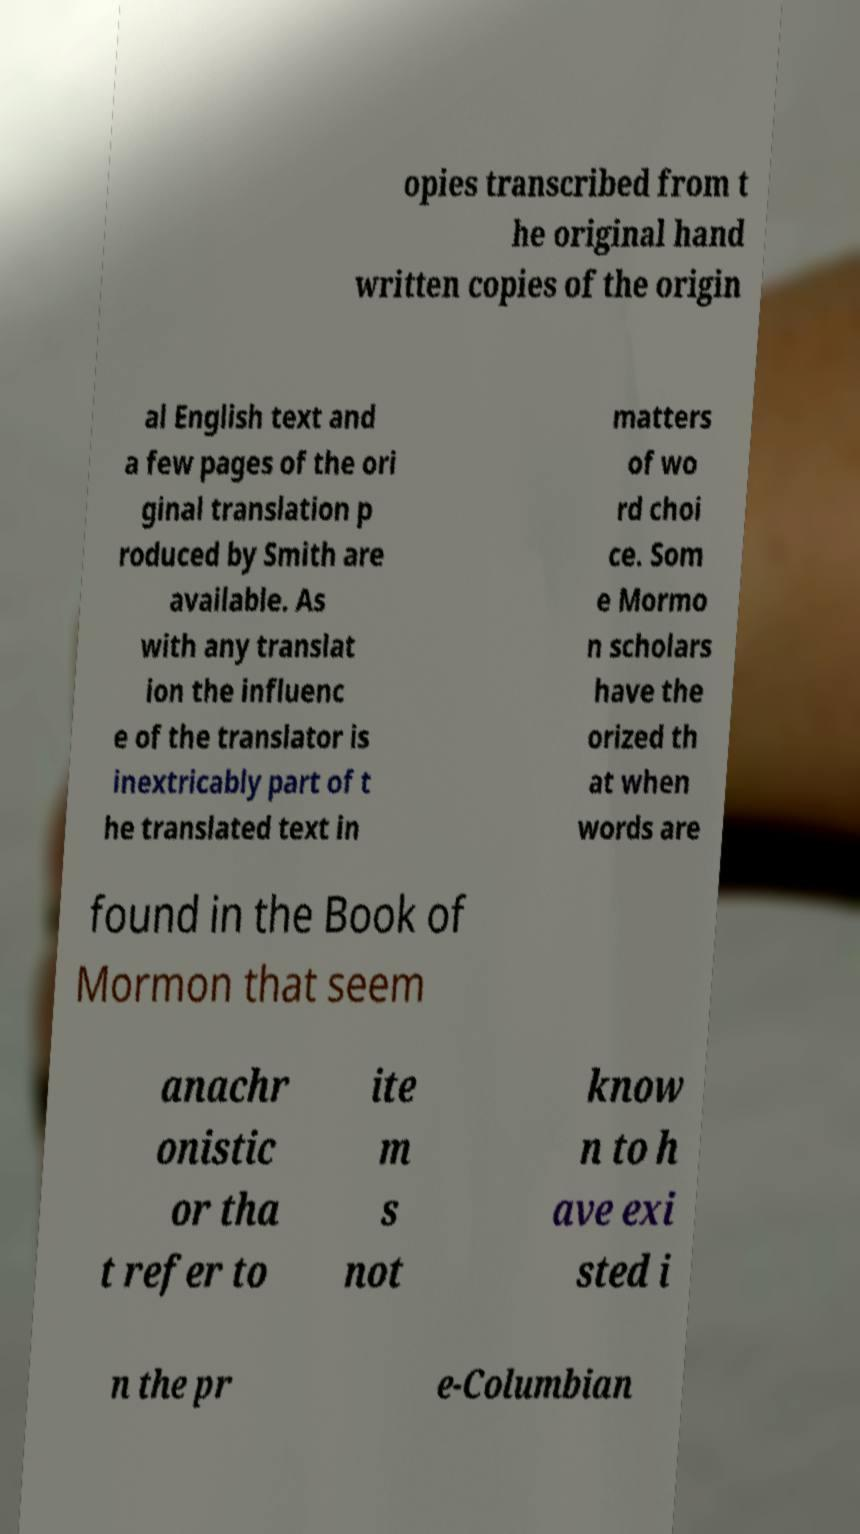Please read and relay the text visible in this image. What does it say? opies transcribed from t he original hand written copies of the origin al English text and a few pages of the ori ginal translation p roduced by Smith are available. As with any translat ion the influenc e of the translator is inextricably part of t he translated text in matters of wo rd choi ce. Som e Mormo n scholars have the orized th at when words are found in the Book of Mormon that seem anachr onistic or tha t refer to ite m s not know n to h ave exi sted i n the pr e-Columbian 